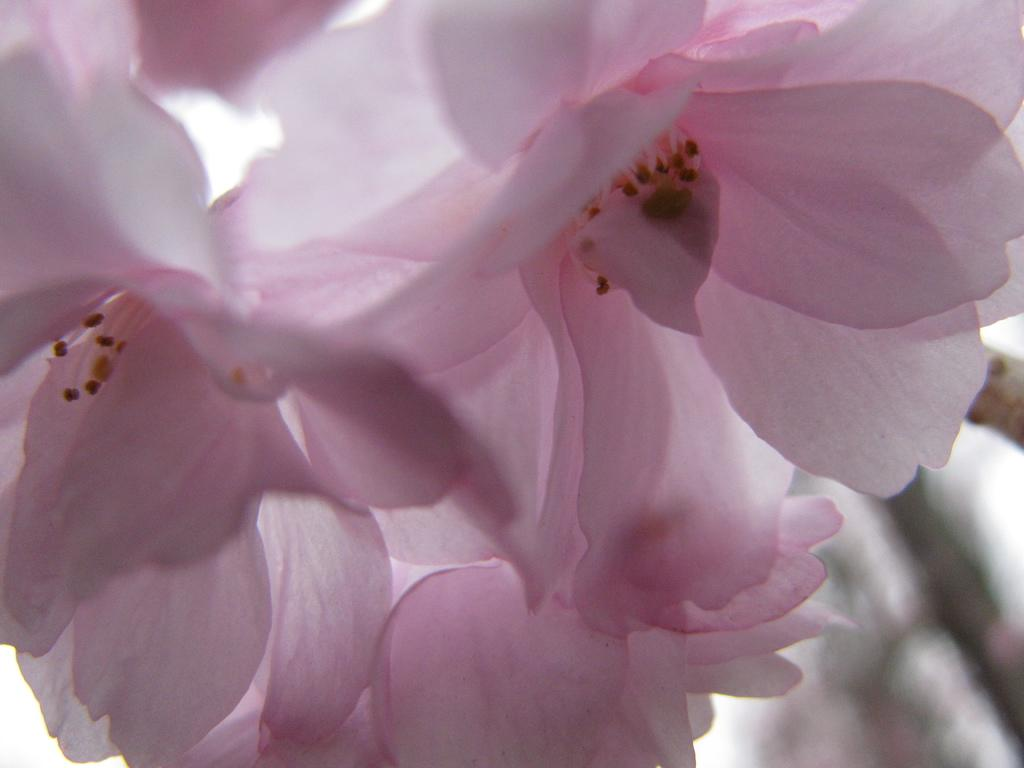What is the dominant color of the flowers in the image? The dominant color of the flowers in the image is pink. Where are the flowers located in the image? The flowers are in the foreground of the image. What knowledge can be gained from the story of the bee in the image? There is no story or bee present in the image, so no knowledge can be gained from it. 